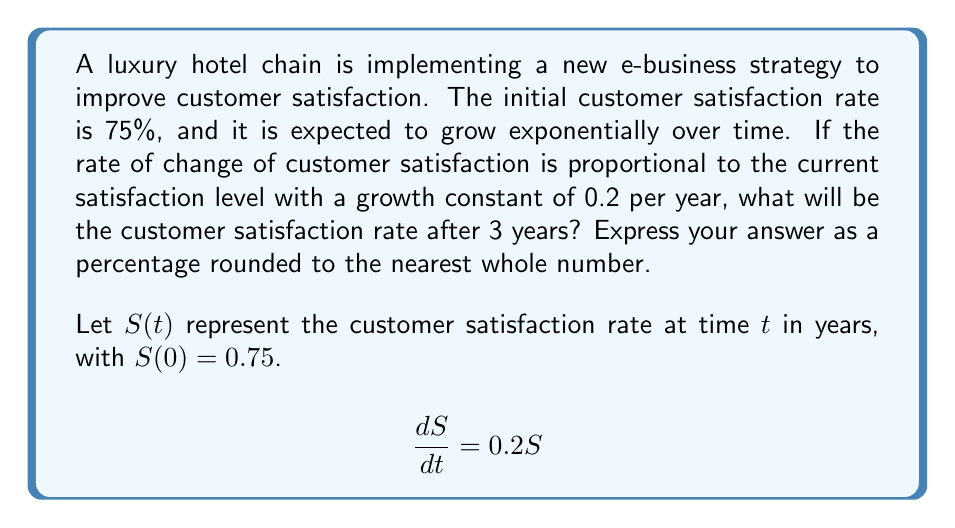Give your solution to this math problem. To solve this problem, we need to use the exponential growth model for ordinary differential equations.

1) The given differential equation is:
   $$\frac{dS}{dt} = 0.2S$$

2) The general solution for this type of equation is:
   $$S(t) = Ce^{0.2t}$$
   where $C$ is a constant we need to determine.

3) We know the initial condition: $S(0) = 0.75$
   Substituting this into our general solution:
   $$0.75 = Ce^{0.2(0)} = C$$

4) Now we have our specific solution:
   $$S(t) = 0.75e^{0.2t}$$

5) To find the satisfaction rate after 3 years, we substitute $t = 3$:
   $$S(3) = 0.75e^{0.2(3)} = 0.75e^{0.6}$$

6) Calculate this value:
   $$S(3) = 0.75 * 1.8221 = 1.3666$$

7) Convert to a percentage:
   $$1.3666 * 100\% = 136.66\%$$

8) Rounding to the nearest whole number:
   $$137\%$$
Answer: 137% 